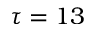Convert formula to latex. <formula><loc_0><loc_0><loc_500><loc_500>\tau = 1 3</formula> 